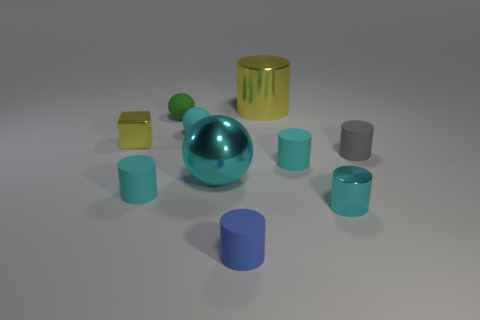Subtract all tiny balls. How many balls are left? 1 Subtract all blocks. How many objects are left? 9 Subtract all cyan spheres. How many spheres are left? 1 Subtract all green cylinders. Subtract all cyan cubes. How many cylinders are left? 6 Add 1 large yellow cylinders. How many large yellow cylinders exist? 2 Subtract 0 red balls. How many objects are left? 10 Subtract all cyan spheres. How many gray cylinders are left? 1 Subtract all tiny gray matte objects. Subtract all small green rubber objects. How many objects are left? 8 Add 8 gray matte objects. How many gray matte objects are left? 9 